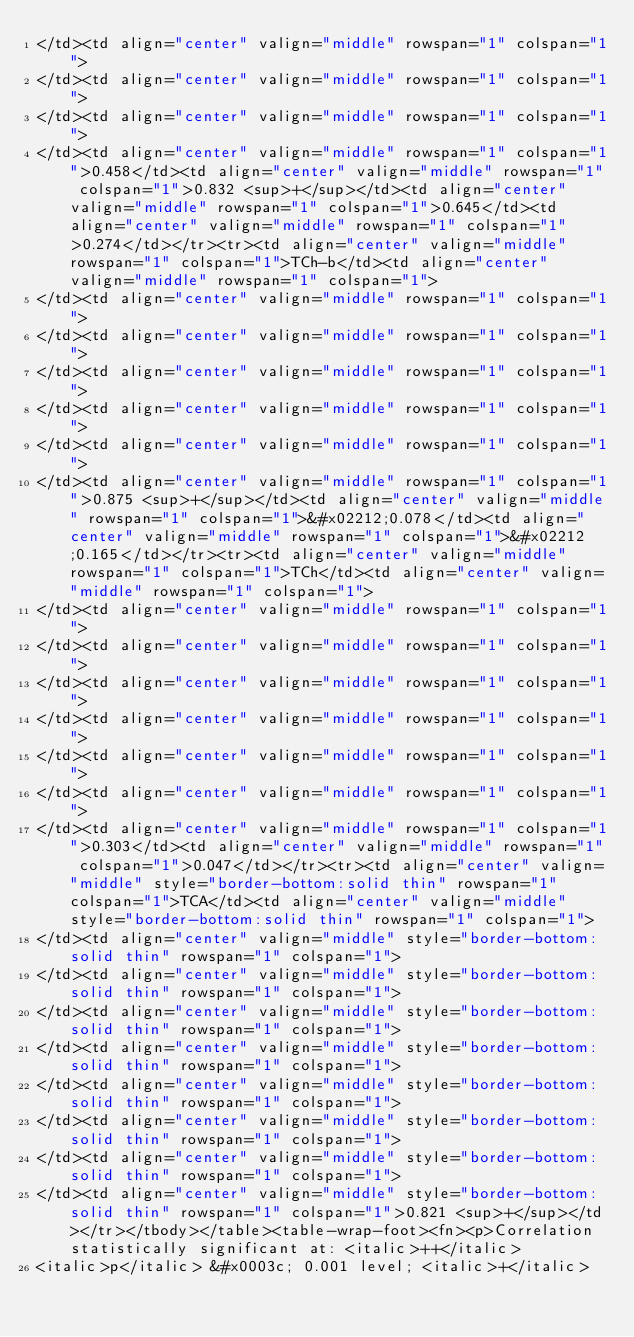Convert code to text. <code><loc_0><loc_0><loc_500><loc_500><_XML_></td><td align="center" valign="middle" rowspan="1" colspan="1">
</td><td align="center" valign="middle" rowspan="1" colspan="1">
</td><td align="center" valign="middle" rowspan="1" colspan="1">
</td><td align="center" valign="middle" rowspan="1" colspan="1">0.458</td><td align="center" valign="middle" rowspan="1" colspan="1">0.832 <sup>+</sup></td><td align="center" valign="middle" rowspan="1" colspan="1">0.645</td><td align="center" valign="middle" rowspan="1" colspan="1">0.274</td></tr><tr><td align="center" valign="middle" rowspan="1" colspan="1">TCh-b</td><td align="center" valign="middle" rowspan="1" colspan="1">
</td><td align="center" valign="middle" rowspan="1" colspan="1">
</td><td align="center" valign="middle" rowspan="1" colspan="1">
</td><td align="center" valign="middle" rowspan="1" colspan="1">
</td><td align="center" valign="middle" rowspan="1" colspan="1">
</td><td align="center" valign="middle" rowspan="1" colspan="1">
</td><td align="center" valign="middle" rowspan="1" colspan="1">0.875 <sup>+</sup></td><td align="center" valign="middle" rowspan="1" colspan="1">&#x02212;0.078</td><td align="center" valign="middle" rowspan="1" colspan="1">&#x02212;0.165</td></tr><tr><td align="center" valign="middle" rowspan="1" colspan="1">TCh</td><td align="center" valign="middle" rowspan="1" colspan="1">
</td><td align="center" valign="middle" rowspan="1" colspan="1">
</td><td align="center" valign="middle" rowspan="1" colspan="1">
</td><td align="center" valign="middle" rowspan="1" colspan="1">
</td><td align="center" valign="middle" rowspan="1" colspan="1">
</td><td align="center" valign="middle" rowspan="1" colspan="1">
</td><td align="center" valign="middle" rowspan="1" colspan="1">
</td><td align="center" valign="middle" rowspan="1" colspan="1">0.303</td><td align="center" valign="middle" rowspan="1" colspan="1">0.047</td></tr><tr><td align="center" valign="middle" style="border-bottom:solid thin" rowspan="1" colspan="1">TCA</td><td align="center" valign="middle" style="border-bottom:solid thin" rowspan="1" colspan="1">
</td><td align="center" valign="middle" style="border-bottom:solid thin" rowspan="1" colspan="1">
</td><td align="center" valign="middle" style="border-bottom:solid thin" rowspan="1" colspan="1">
</td><td align="center" valign="middle" style="border-bottom:solid thin" rowspan="1" colspan="1">
</td><td align="center" valign="middle" style="border-bottom:solid thin" rowspan="1" colspan="1">
</td><td align="center" valign="middle" style="border-bottom:solid thin" rowspan="1" colspan="1">
</td><td align="center" valign="middle" style="border-bottom:solid thin" rowspan="1" colspan="1">
</td><td align="center" valign="middle" style="border-bottom:solid thin" rowspan="1" colspan="1">
</td><td align="center" valign="middle" style="border-bottom:solid thin" rowspan="1" colspan="1">0.821 <sup>+</sup></td></tr></tbody></table><table-wrap-foot><fn><p>Correlation statistically significant at: <italic>++</italic>
<italic>p</italic> &#x0003c; 0.001 level; <italic>+</italic></code> 